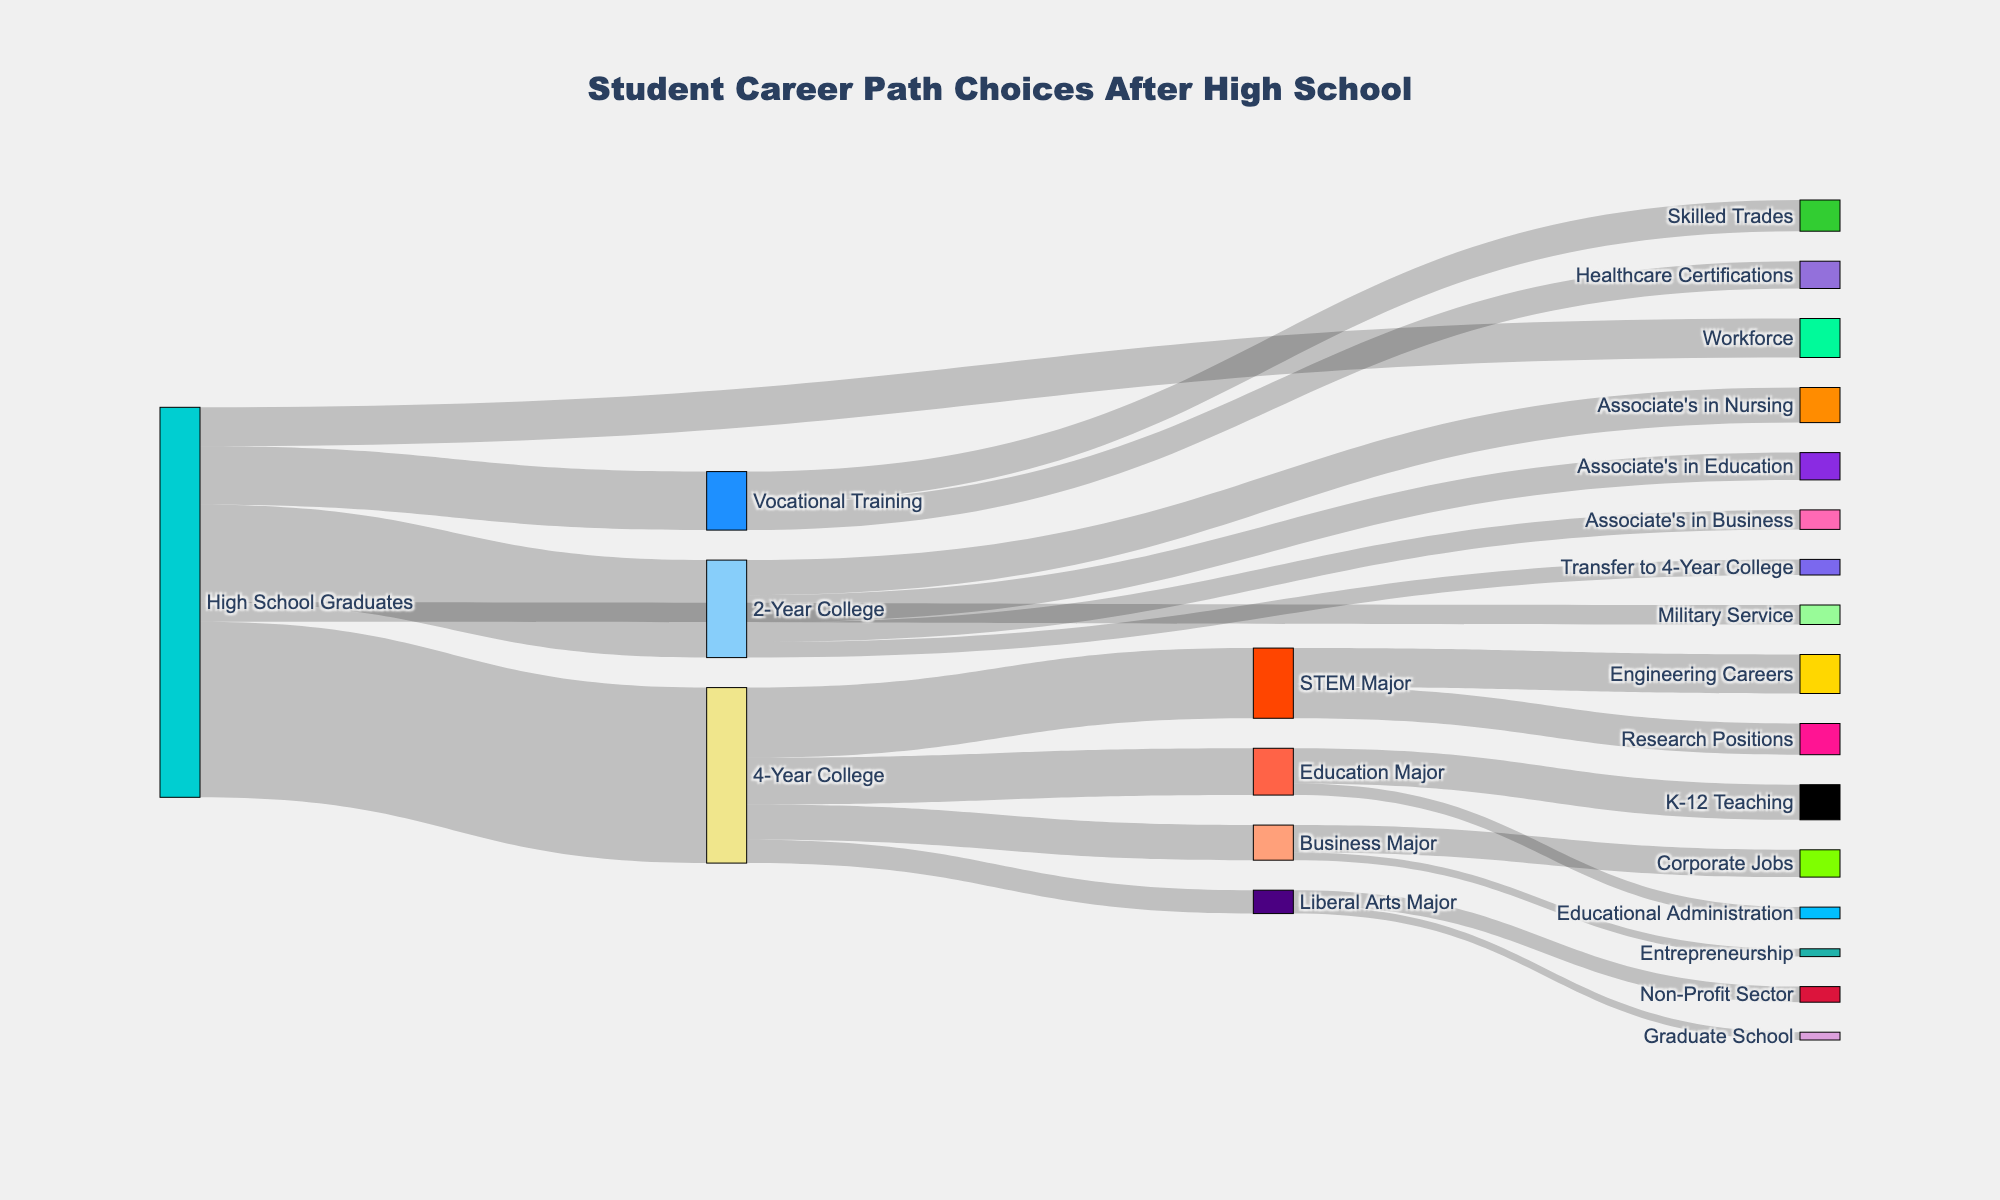What's the most popular post-high school path chosen by students? The most popular post-high school path is the one with the largest value flowing from "High School Graduates" to its targets. "4-Year College" has the highest value of 450.
Answer: 4-Year College How many students chose Military Service after high school? The value flowing from "High School Graduates" to "Military Service" is 50, which represents the number of students.
Answer: 50 Which major has the most students within the 4-Year College path? Among the values flowing from "4-Year College" to different majors, "STEM Major" has the highest value of 180.
Answer: STEM Major What's the total number of students pursuing an associate's degree in business? The value flowing from "2-Year College" to "Associate's in Business" is 50.
Answer: 50 Compare the number of students entering the workforce directly to those entering military service. The values are 100 for the workforce and 50 for military service. Since 100 is greater than 50, more students entered the workforce.
Answer: Workforce has more After choosing Vocational Training, which field attracts more students: Skilled Trades or Healthcare Certifications? The values are 80 for Skilled Trades and 70 for Healthcare Certifications. 80 is greater than 70, so Skilled Trades attracts more students.
Answer: Skilled Trades What's the total number of students pursuing Education-related careers? Sum the values for "K-12 Teaching" and "Educational Administration", which are 90 and 30 respectively, totaling to 120.
Answer: 120 How many students transitioned from a 2-Year College to a 4-Year College? The value flowing from "2-Year College" to "Transfer to 4-Year College" is 40.
Answer: 40 Within STEM Majors, which career path has more students: Engineering Careers or Research Positions? The values are 100 for Engineering Careers and 80 for Research Positions. 100 is greater than 80, so Engineering Careers has more students.
Answer: Engineering Careers 